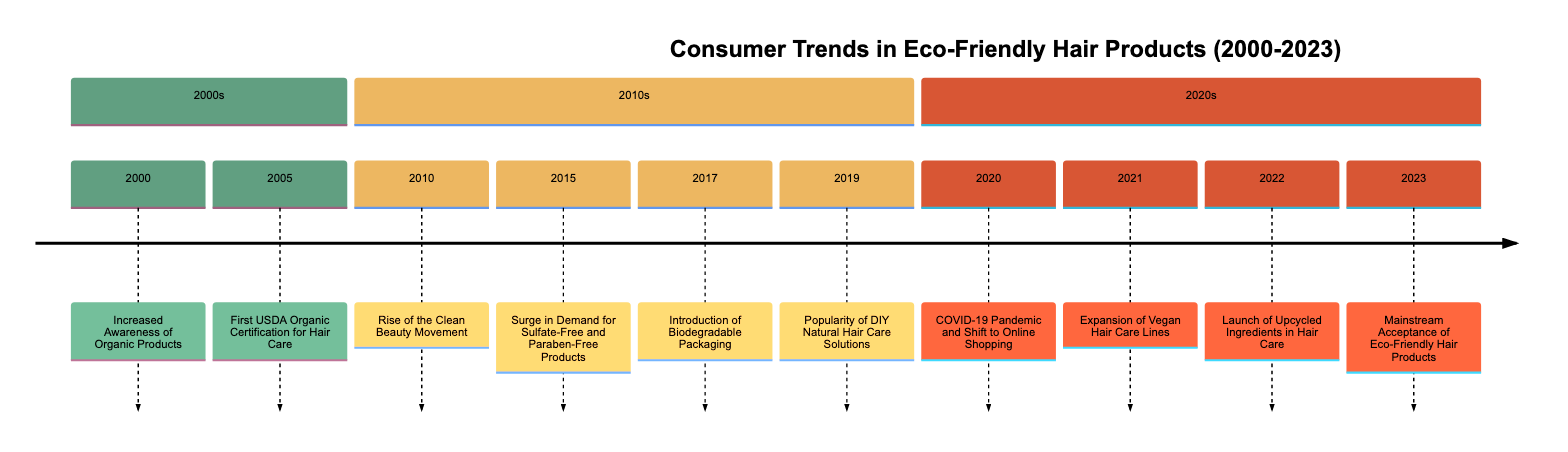What significant event occurred in 2005 related to hair care? The diagram shows that in 2005, the significant event was the "First USDA Organic Certification for Hair Care." This information is directly provided in the timeline for that year.
Answer: First USDA Organic Certification for Hair Care How many significant events are listed for the 2010s? The timeline section for the 2010s includes five events: 2010, 2015, 2017, and 2019. Counting these gives the total number of events.
Answer: 5 What year did the Clean Beauty Movement rise? According to the timeline, the rise of the Clean Beauty Movement took place in 2010, as indicated by the event listed for that year.
Answer: 2010 Which event marks the introduction of biodegradable packaging? The year 2017 on the timeline marks the "Introduction of Biodegradable Packaging." This can be seen by directly referencing the event for that year.
Answer: Introduction of Biodegradable Packaging What trend gained popularity in 2019? The diagram indicates that in 2019, there was a rise in the "Popularity of DIY Natural Hair Care Solutions." The event for that year clearly states this trend.
Answer: Popularity of DIY Natural Hair Care Solutions What was a key consumer shift during the COVID-19 pandemic in 2020? The timeline shows that in 2020, due to the COVID-19 pandemic, there was a "Shift to Online Shopping" along with increased interest in sustainable brands. This is described in the event details for that year.
Answer: Shift to Online Shopping Which year corresponds to the mainstream acceptance of eco-friendly hair products? The final event listed in the year 2023 indicates the "Mainstream Acceptance of Eco-Friendly Hair Products." This is straightforward as it is the last event detailed in the timeline.
Answer: 2023 What event occurred immediately before the launch of upcycled ingredients in hair care? The event prior to the launch of upcycled ingredients in hair care, which took place in 2022, is the "Expansion of Vegan Hair Care Lines" from 2021, as seen when moving back through the timeline.
Answer: Expansion of Vegan Hair Care Lines Which section of the timeline includes an increasing consumer preference for sulfate-free products? The section for the 2010s includes the event in 2015 that represents the surge in demand for sulfate-free and paraben-free products, indicating this consumer preference.
Answer: 2010s 